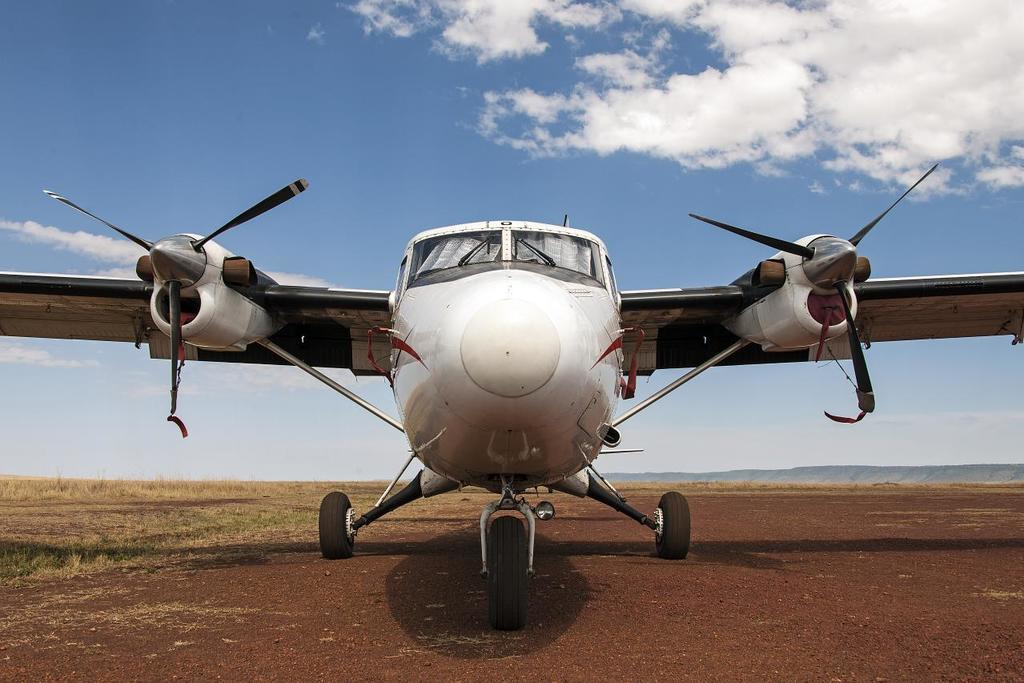What is the main subject of the image? The main subject of the image is an aircraft on the ground. What can be seen on the ground beside the aircraft? There is grass on the ground beside the aircraft. What is visible in the background of the image? Mountains are visible in the background of the image. What is visible at the top of the image? The sky is visible at the top of the image. What type of tub is located near the aircraft in the image? There is no tub present in the image; it features an aircraft on the ground with grass and mountains in the background. 